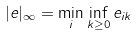Convert formula to latex. <formula><loc_0><loc_0><loc_500><loc_500>| e | _ { \infty } = \min _ { i } \inf _ { k \geq 0 } e _ { i k }</formula> 